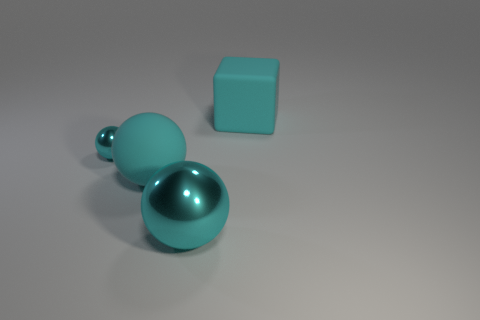There is a small ball that is the same color as the large metallic ball; what is its material?
Keep it short and to the point. Metal. There is a cyan sphere that is behind the big cyan rubber thing that is in front of the small cyan object; what is its material?
Give a very brief answer. Metal. Is the number of matte blocks on the left side of the small cyan object the same as the number of large cyan balls in front of the cyan matte block?
Provide a short and direct response. No. What number of things are metal things that are in front of the matte ball or cyan balls that are in front of the tiny metal thing?
Provide a short and direct response. 2. The big cyan object that is on the right side of the matte ball and in front of the small shiny sphere is made of what material?
Ensure brevity in your answer.  Metal. There is a metallic object behind the big cyan thing that is on the left side of the sphere that is on the right side of the big cyan matte sphere; what size is it?
Provide a succinct answer. Small. Is the number of cyan metal objects greater than the number of blocks?
Ensure brevity in your answer.  Yes. Does the cyan thing behind the tiny sphere have the same material as the small sphere?
Keep it short and to the point. No. Are there fewer large cyan objects than objects?
Keep it short and to the point. Yes. Are there any cyan objects that are behind the large cyan thing on the right side of the cyan metallic ball right of the tiny cyan ball?
Your answer should be compact. No. 